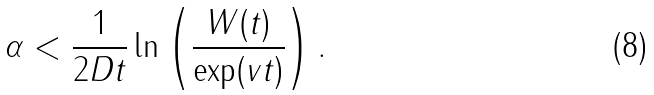Convert formula to latex. <formula><loc_0><loc_0><loc_500><loc_500>\alpha < { \frac { 1 } { 2 D t } } \ln \left ( \frac { W ( t ) } { \exp ( v t ) } \right ) .</formula> 